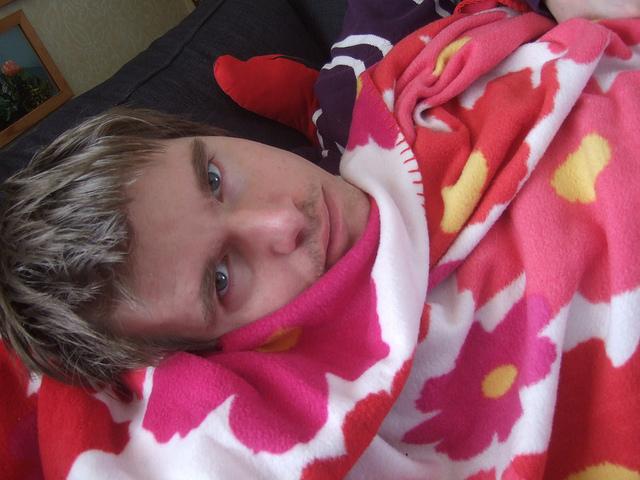Is this a full grown adult?
Write a very short answer. Yes. Is there a camera in the photo?
Quick response, please. No. What color is the blanket?
Concise answer only. Pink and white. What color is the pillow behind his head?
Concise answer only. Black. What is wrapped around the person?
Answer briefly. Blanket. 